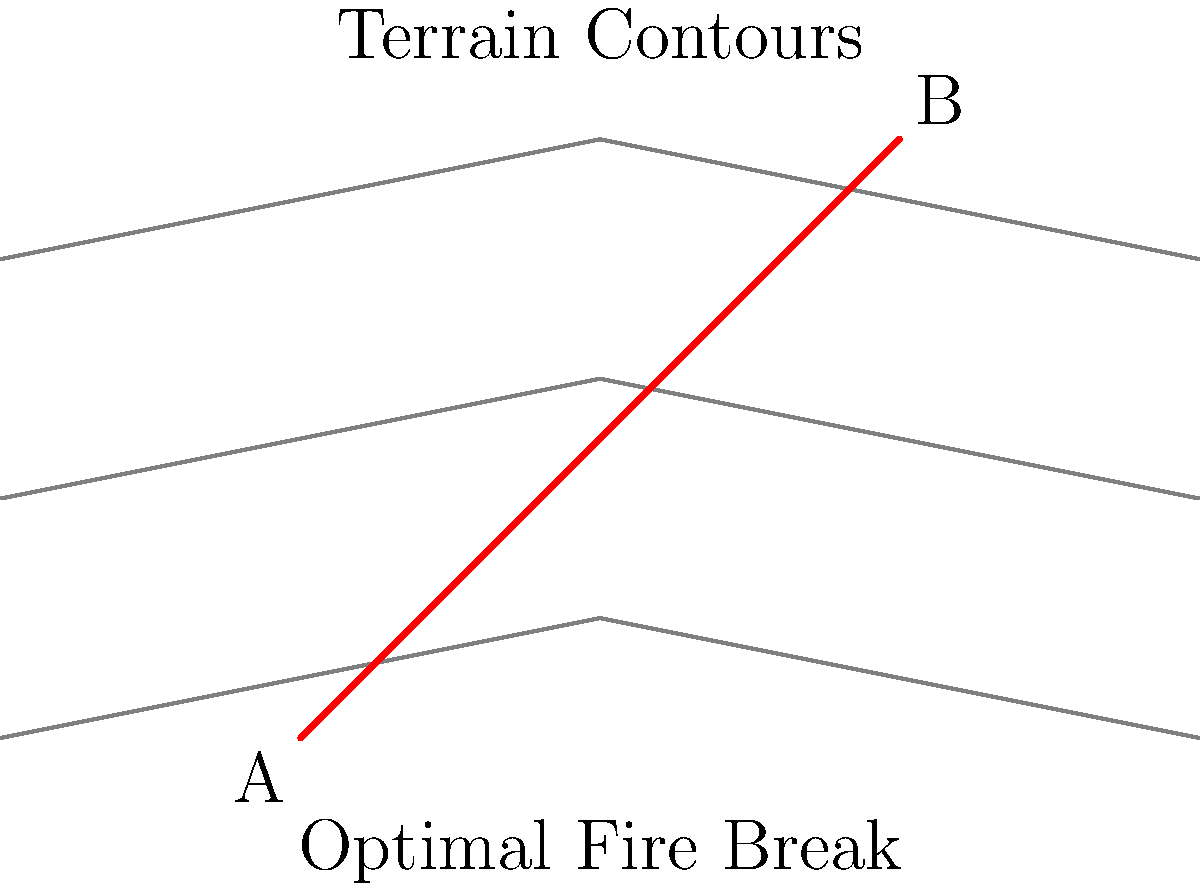Given a terrain map with contour lines as shown, a fire break needs to be established from point A (50,0) to point B (150,100). Assuming the cost of creating the fire break is proportional to its length and inversely proportional to the terrain slope, determine the equation of the optimal fire break line that minimizes the cost. Use the coordinate system where each unit represents 10 meters. To determine the optimal fire break line, we need to follow these steps:

1) The optimal path in this scenario is a straight line from A to B, as it balances the length and slope factors.

2) We can determine the equation of this line using the point-slope form:

   $y - y_1 = m(x - x_1)$

   where $m$ is the slope of the line.

3) Calculate the slope:
   $m = \frac{y_2 - y_1}{x_2 - x_1} = \frac{100 - 0}{150 - 50} = \frac{100}{100} = 1$

4) Use point A (50,0) and the calculated slope in the point-slope form:

   $y - 0 = 1(x - 50)$

5) Simplify to slope-intercept form:

   $y = x - 50$

6) This equation represents the optimal fire break line in the given coordinate system, where each unit represents 10 meters.
Answer: $y = x - 50$ 